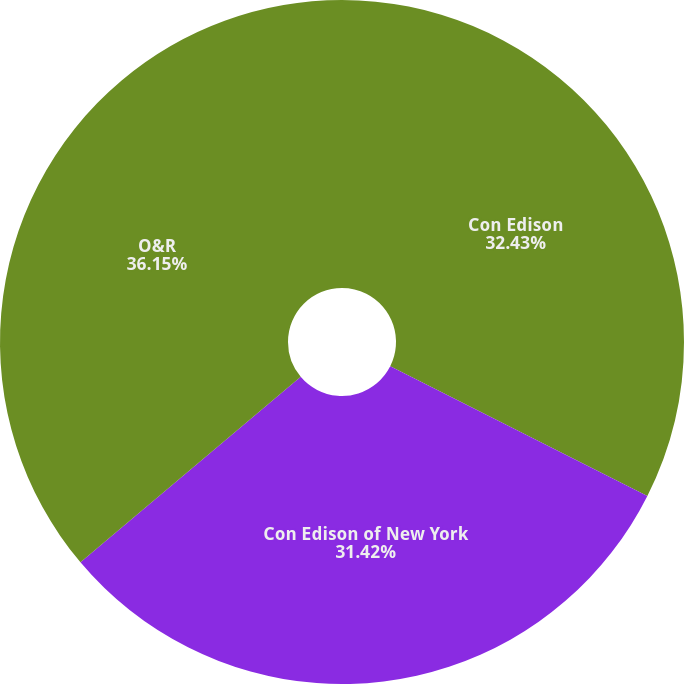<chart> <loc_0><loc_0><loc_500><loc_500><pie_chart><fcel>Con Edison<fcel>Con Edison of New York<fcel>O&R<nl><fcel>32.43%<fcel>31.42%<fcel>36.14%<nl></chart> 